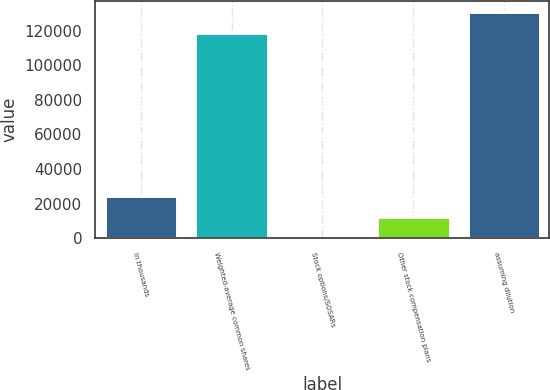Convert chart. <chart><loc_0><loc_0><loc_500><loc_500><bar_chart><fcel>in thousands<fcel>Weighted-average common shares<fcel>Stock options/SOSARs<fcel>Other stock compensation plans<fcel>assuming dilution<nl><fcel>24101.2<fcel>118891<fcel>269<fcel>12185.1<fcel>130807<nl></chart> 